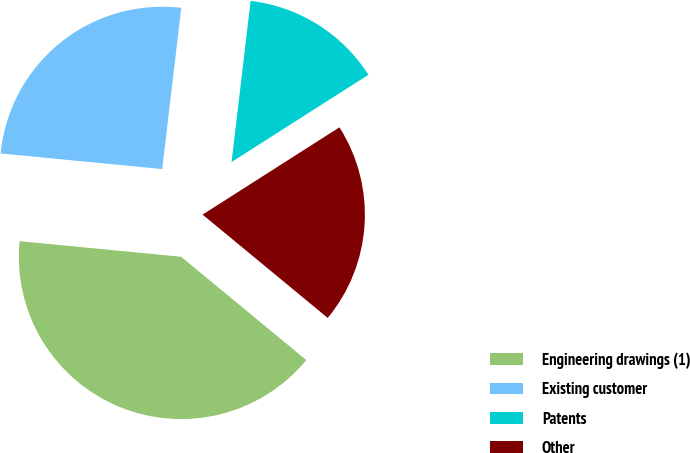Convert chart. <chart><loc_0><loc_0><loc_500><loc_500><pie_chart><fcel>Engineering drawings (1)<fcel>Existing customer<fcel>Patents<fcel>Other<nl><fcel>40.55%<fcel>25.34%<fcel>14.09%<fcel>20.02%<nl></chart> 